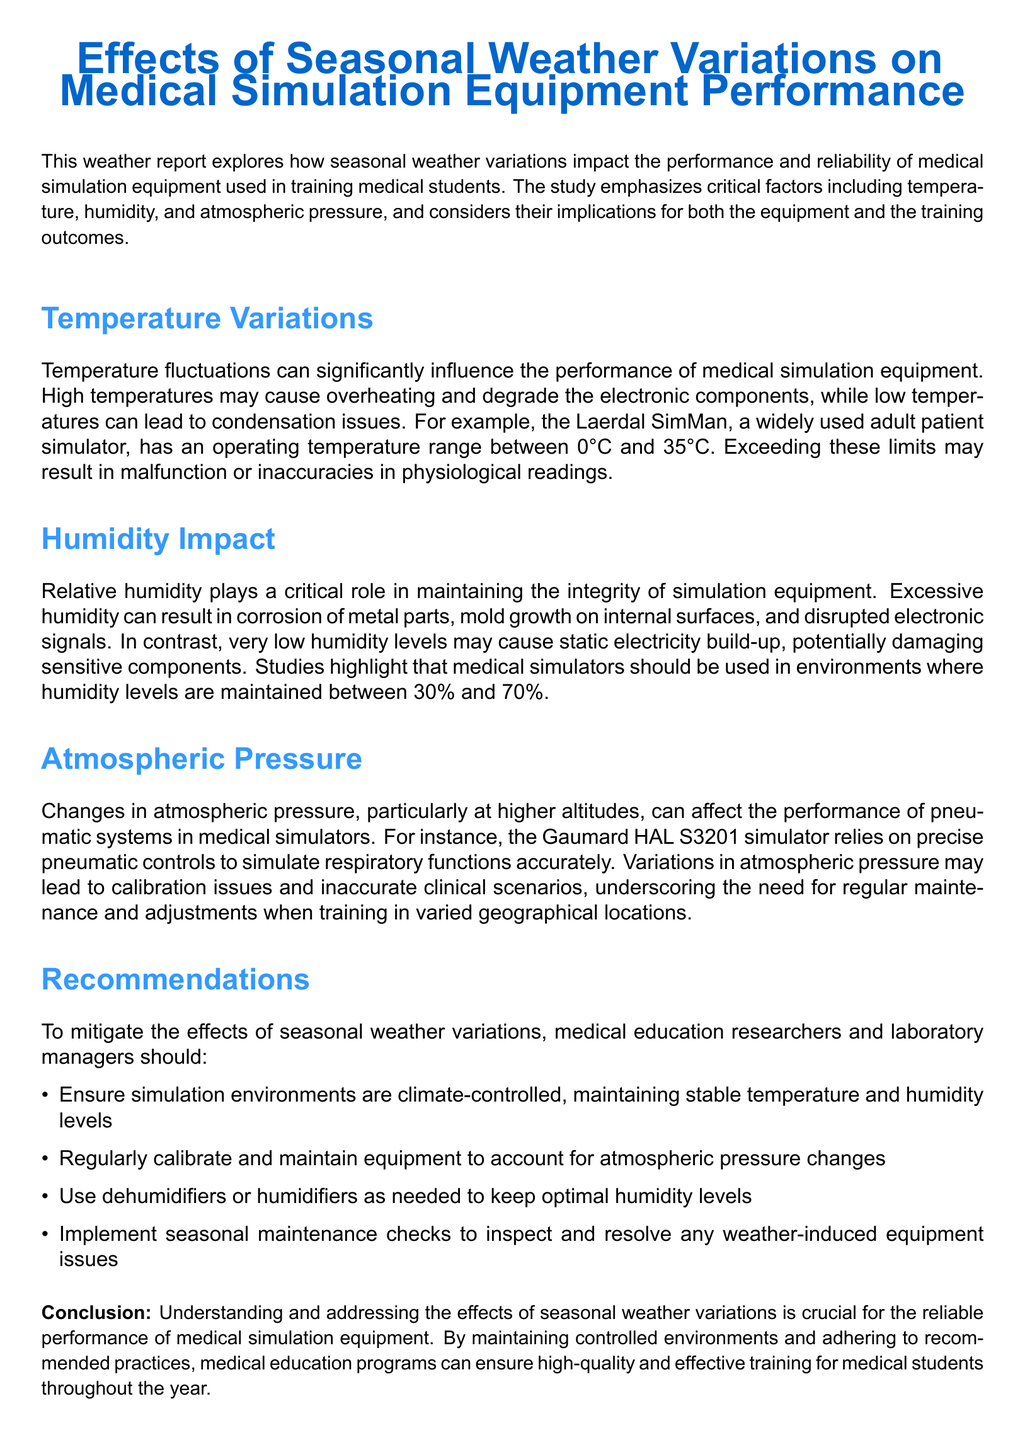What is the optimal humidity range for medical simulators? The document states that medical simulators should be used in environments where humidity levels are maintained between 30% and 70%.
Answer: 30% and 70% What equipment temperature can cause overheating? The report indicates that high temperatures exceeding 35°C may cause overheating and degrade electronic components in simulators.
Answer: 35°C Which medical simulator is mentioned regarding temperature limits? The document specifically references the Laerdal SimMan as a widely used adult patient simulator with defined operating temperature limits.
Answer: Laerdal SimMan How can excessive humidity affect simulation equipment? The report explains that excessive humidity can result in corrosion of metal parts, mold growth, and disrupted electronic signals.
Answer: Corrosion, mold growth, disrupted signals What regular maintenance practice is recommended? Regular calibration and maintenance of equipment is suggested to account for atmospheric pressure changes.
Answer: Calibration and maintenance Which pneumatic simulator is affected by atmospheric pressure? The report mentions the Gaumard HAL S3201 simulator as relying on pneumatic controls impacted by atmospheric pressure variations.
Answer: Gaumard HAL S3201 What should be implemented to address weather-induced issues? The document recommends implementing seasonal maintenance checks to inspect and resolve weather-induced equipment issues.
Answer: Seasonal maintenance checks What is the primary focus of this weather report? The report explores how seasonal weather variations impact the performance and reliability of medical simulation equipment.
Answer: Performance and reliability of medical simulation equipment What is the conclusion of the report? The report concludes that understanding and addressing the effects of seasonal weather variations is crucial for reliable performance of equipment.
Answer: Crucial for reliable performance of equipment 